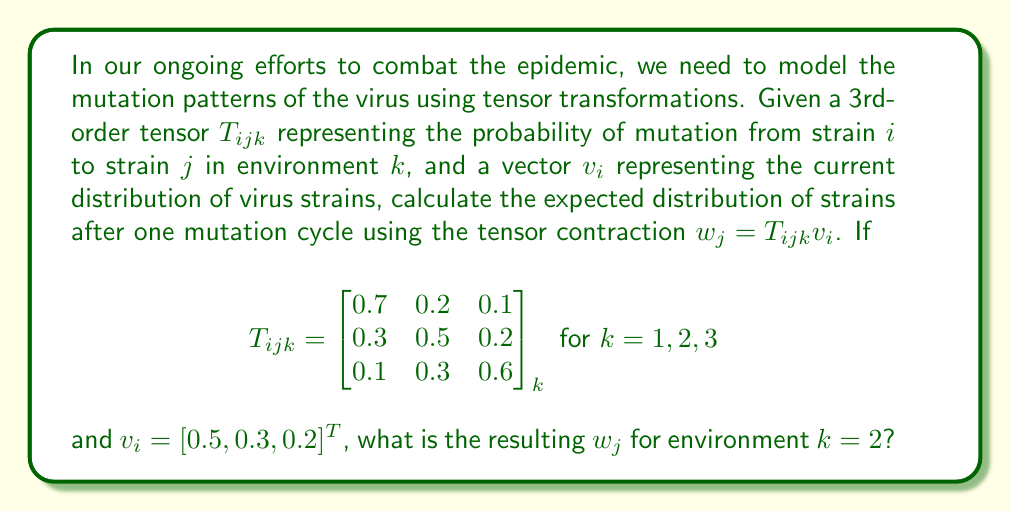Provide a solution to this math problem. To solve this problem, we need to perform a tensor contraction between the 3rd-order tensor $T_{ijk}$ and the vector $v_i$. The resulting $w_j$ is calculated as:

$$w_j = T_{ijk}v_i = \sum_i T_{ijk}v_i$$

For environment $k=2$, we use the middle matrix of $T_{ijk}$:

$$T_{ij2} = \begin{bmatrix}
0.7 & 0.2 & 0.1 \\
0.3 & 0.5 & 0.2 \\
0.1 & 0.3 & 0.6
\end{bmatrix}$$

Now, let's calculate each component of $w_j$:

1. For $j=1$:
   $$w_1 = (0.7 \times 0.5) + (0.3 \times 0.3) + (0.1 \times 0.2) = 0.35 + 0.09 + 0.02 = 0.46$$

2. For $j=2$:
   $$w_2 = (0.2 \times 0.5) + (0.5 \times 0.3) + (0.3 \times 0.2) = 0.10 + 0.15 + 0.06 = 0.31$$

3. For $j=3$:
   $$w_3 = (0.1 \times 0.5) + (0.2 \times 0.3) + (0.6 \times 0.2) = 0.05 + 0.06 + 0.12 = 0.23$$

Therefore, the resulting $w_j$ for environment $k=2$ is $[0.46, 0.31, 0.23]^T$.
Answer: $w_j = [0.46, 0.31, 0.23]^T$ 